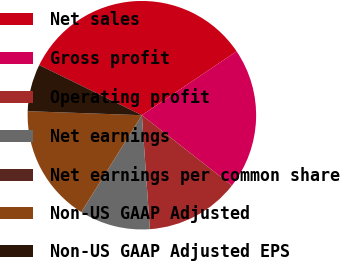Convert chart to OTSL. <chart><loc_0><loc_0><loc_500><loc_500><pie_chart><fcel>Net sales<fcel>Gross profit<fcel>Operating profit<fcel>Net earnings<fcel>Net earnings per common share<fcel>Non-US GAAP Adjusted<fcel>Non-US GAAP Adjusted EPS<nl><fcel>33.32%<fcel>20.0%<fcel>13.33%<fcel>10.0%<fcel>0.01%<fcel>16.66%<fcel>6.67%<nl></chart> 